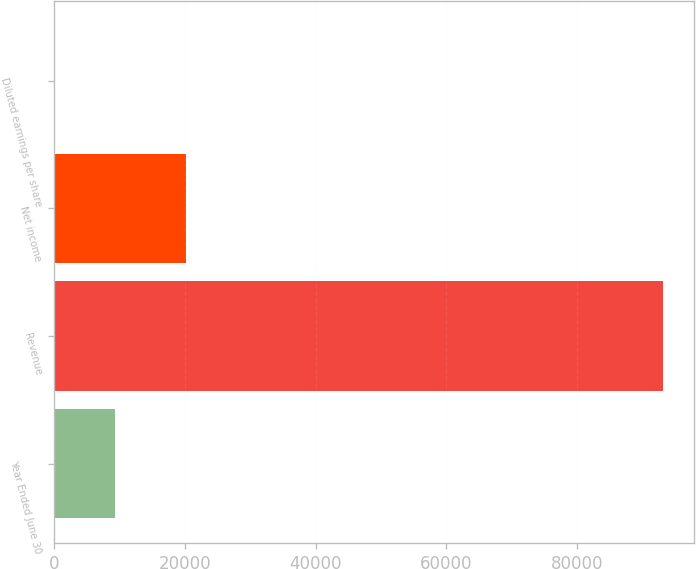Convert chart. <chart><loc_0><loc_0><loc_500><loc_500><bar_chart><fcel>Year Ended June 30<fcel>Revenue<fcel>Net income<fcel>Diluted earnings per share<nl><fcel>9326.44<fcel>93243<fcel>20153<fcel>2.38<nl></chart> 